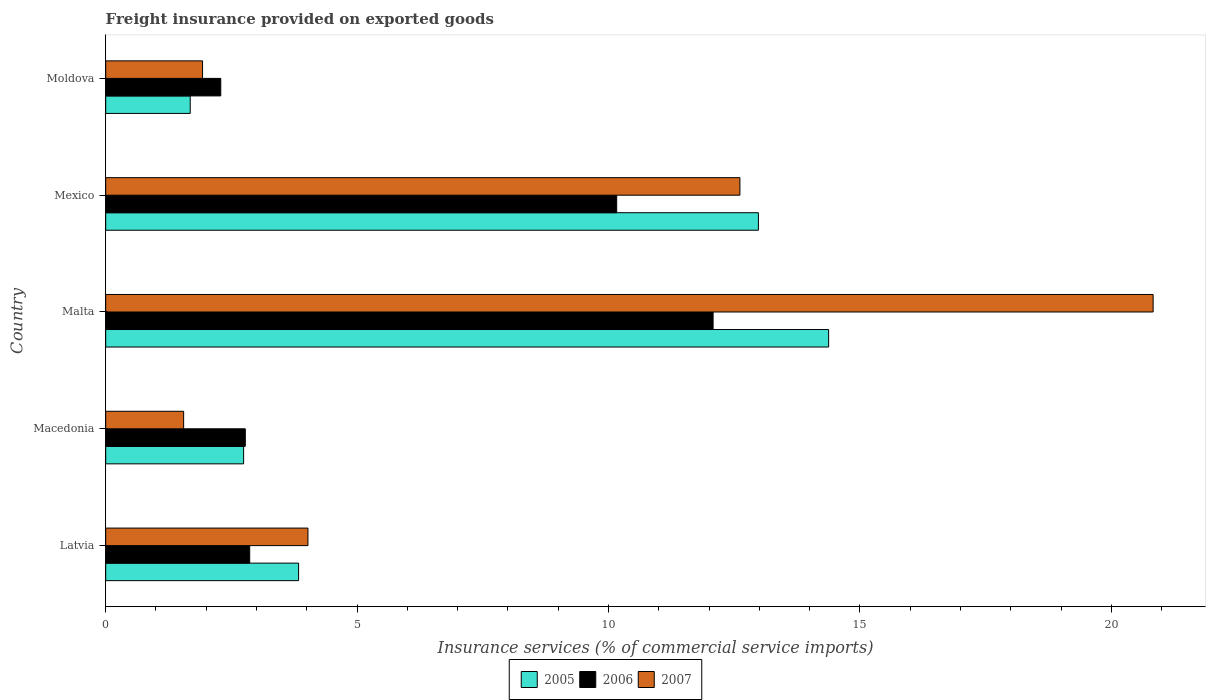How many different coloured bars are there?
Give a very brief answer. 3. How many groups of bars are there?
Your response must be concise. 5. Are the number of bars per tick equal to the number of legend labels?
Provide a succinct answer. Yes. What is the label of the 3rd group of bars from the top?
Your response must be concise. Malta. In how many cases, is the number of bars for a given country not equal to the number of legend labels?
Provide a short and direct response. 0. What is the freight insurance provided on exported goods in 2006 in Moldova?
Keep it short and to the point. 2.29. Across all countries, what is the maximum freight insurance provided on exported goods in 2007?
Make the answer very short. 20.83. Across all countries, what is the minimum freight insurance provided on exported goods in 2005?
Your response must be concise. 1.68. In which country was the freight insurance provided on exported goods in 2005 maximum?
Offer a terse response. Malta. In which country was the freight insurance provided on exported goods in 2006 minimum?
Your response must be concise. Moldova. What is the total freight insurance provided on exported goods in 2005 in the graph?
Your response must be concise. 35.62. What is the difference between the freight insurance provided on exported goods in 2005 in Latvia and that in Malta?
Your answer should be compact. -10.54. What is the difference between the freight insurance provided on exported goods in 2006 in Malta and the freight insurance provided on exported goods in 2005 in Mexico?
Keep it short and to the point. -0.9. What is the average freight insurance provided on exported goods in 2005 per country?
Your answer should be compact. 7.12. What is the difference between the freight insurance provided on exported goods in 2005 and freight insurance provided on exported goods in 2006 in Moldova?
Ensure brevity in your answer.  -0.61. In how many countries, is the freight insurance provided on exported goods in 2005 greater than 3 %?
Make the answer very short. 3. What is the ratio of the freight insurance provided on exported goods in 2005 in Latvia to that in Mexico?
Ensure brevity in your answer.  0.3. Is the difference between the freight insurance provided on exported goods in 2005 in Macedonia and Malta greater than the difference between the freight insurance provided on exported goods in 2006 in Macedonia and Malta?
Offer a very short reply. No. What is the difference between the highest and the second highest freight insurance provided on exported goods in 2006?
Offer a very short reply. 1.92. What is the difference between the highest and the lowest freight insurance provided on exported goods in 2006?
Keep it short and to the point. 9.79. What does the 2nd bar from the top in Moldova represents?
Your answer should be compact. 2006. Where does the legend appear in the graph?
Keep it short and to the point. Bottom center. How many legend labels are there?
Offer a very short reply. 3. What is the title of the graph?
Make the answer very short. Freight insurance provided on exported goods. Does "2010" appear as one of the legend labels in the graph?
Give a very brief answer. No. What is the label or title of the X-axis?
Keep it short and to the point. Insurance services (% of commercial service imports). What is the Insurance services (% of commercial service imports) in 2005 in Latvia?
Keep it short and to the point. 3.84. What is the Insurance services (% of commercial service imports) of 2006 in Latvia?
Make the answer very short. 2.86. What is the Insurance services (% of commercial service imports) in 2007 in Latvia?
Offer a terse response. 4.02. What is the Insurance services (% of commercial service imports) of 2005 in Macedonia?
Give a very brief answer. 2.74. What is the Insurance services (% of commercial service imports) of 2006 in Macedonia?
Give a very brief answer. 2.78. What is the Insurance services (% of commercial service imports) of 2007 in Macedonia?
Offer a terse response. 1.55. What is the Insurance services (% of commercial service imports) of 2005 in Malta?
Keep it short and to the point. 14.38. What is the Insurance services (% of commercial service imports) in 2006 in Malta?
Give a very brief answer. 12.08. What is the Insurance services (% of commercial service imports) of 2007 in Malta?
Ensure brevity in your answer.  20.83. What is the Insurance services (% of commercial service imports) in 2005 in Mexico?
Offer a very short reply. 12.98. What is the Insurance services (% of commercial service imports) of 2006 in Mexico?
Your response must be concise. 10.16. What is the Insurance services (% of commercial service imports) of 2007 in Mexico?
Your answer should be compact. 12.61. What is the Insurance services (% of commercial service imports) of 2005 in Moldova?
Offer a terse response. 1.68. What is the Insurance services (% of commercial service imports) in 2006 in Moldova?
Keep it short and to the point. 2.29. What is the Insurance services (% of commercial service imports) of 2007 in Moldova?
Your answer should be compact. 1.93. Across all countries, what is the maximum Insurance services (% of commercial service imports) in 2005?
Your answer should be very brief. 14.38. Across all countries, what is the maximum Insurance services (% of commercial service imports) in 2006?
Offer a very short reply. 12.08. Across all countries, what is the maximum Insurance services (% of commercial service imports) of 2007?
Make the answer very short. 20.83. Across all countries, what is the minimum Insurance services (% of commercial service imports) of 2005?
Your answer should be compact. 1.68. Across all countries, what is the minimum Insurance services (% of commercial service imports) in 2006?
Your answer should be very brief. 2.29. Across all countries, what is the minimum Insurance services (% of commercial service imports) in 2007?
Make the answer very short. 1.55. What is the total Insurance services (% of commercial service imports) of 2005 in the graph?
Your response must be concise. 35.62. What is the total Insurance services (% of commercial service imports) of 2006 in the graph?
Make the answer very short. 30.17. What is the total Insurance services (% of commercial service imports) in 2007 in the graph?
Provide a succinct answer. 40.94. What is the difference between the Insurance services (% of commercial service imports) of 2005 in Latvia and that in Macedonia?
Ensure brevity in your answer.  1.09. What is the difference between the Insurance services (% of commercial service imports) in 2006 in Latvia and that in Macedonia?
Your answer should be compact. 0.09. What is the difference between the Insurance services (% of commercial service imports) in 2007 in Latvia and that in Macedonia?
Provide a short and direct response. 2.47. What is the difference between the Insurance services (% of commercial service imports) of 2005 in Latvia and that in Malta?
Your answer should be very brief. -10.54. What is the difference between the Insurance services (% of commercial service imports) in 2006 in Latvia and that in Malta?
Offer a very short reply. -9.22. What is the difference between the Insurance services (% of commercial service imports) in 2007 in Latvia and that in Malta?
Your answer should be compact. -16.81. What is the difference between the Insurance services (% of commercial service imports) of 2005 in Latvia and that in Mexico?
Your response must be concise. -9.15. What is the difference between the Insurance services (% of commercial service imports) in 2006 in Latvia and that in Mexico?
Make the answer very short. -7.3. What is the difference between the Insurance services (% of commercial service imports) of 2007 in Latvia and that in Mexico?
Give a very brief answer. -8.59. What is the difference between the Insurance services (% of commercial service imports) of 2005 in Latvia and that in Moldova?
Provide a short and direct response. 2.16. What is the difference between the Insurance services (% of commercial service imports) in 2006 in Latvia and that in Moldova?
Your answer should be compact. 0.58. What is the difference between the Insurance services (% of commercial service imports) of 2007 in Latvia and that in Moldova?
Your response must be concise. 2.1. What is the difference between the Insurance services (% of commercial service imports) in 2005 in Macedonia and that in Malta?
Your answer should be compact. -11.64. What is the difference between the Insurance services (% of commercial service imports) of 2006 in Macedonia and that in Malta?
Offer a very short reply. -9.3. What is the difference between the Insurance services (% of commercial service imports) of 2007 in Macedonia and that in Malta?
Your answer should be compact. -19.28. What is the difference between the Insurance services (% of commercial service imports) in 2005 in Macedonia and that in Mexico?
Provide a succinct answer. -10.24. What is the difference between the Insurance services (% of commercial service imports) of 2006 in Macedonia and that in Mexico?
Your answer should be very brief. -7.39. What is the difference between the Insurance services (% of commercial service imports) of 2007 in Macedonia and that in Mexico?
Your answer should be compact. -11.06. What is the difference between the Insurance services (% of commercial service imports) of 2005 in Macedonia and that in Moldova?
Keep it short and to the point. 1.06. What is the difference between the Insurance services (% of commercial service imports) in 2006 in Macedonia and that in Moldova?
Offer a very short reply. 0.49. What is the difference between the Insurance services (% of commercial service imports) in 2007 in Macedonia and that in Moldova?
Offer a very short reply. -0.38. What is the difference between the Insurance services (% of commercial service imports) of 2005 in Malta and that in Mexico?
Give a very brief answer. 1.4. What is the difference between the Insurance services (% of commercial service imports) of 2006 in Malta and that in Mexico?
Your answer should be very brief. 1.92. What is the difference between the Insurance services (% of commercial service imports) in 2007 in Malta and that in Mexico?
Give a very brief answer. 8.22. What is the difference between the Insurance services (% of commercial service imports) of 2005 in Malta and that in Moldova?
Give a very brief answer. 12.7. What is the difference between the Insurance services (% of commercial service imports) of 2006 in Malta and that in Moldova?
Make the answer very short. 9.79. What is the difference between the Insurance services (% of commercial service imports) of 2007 in Malta and that in Moldova?
Give a very brief answer. 18.91. What is the difference between the Insurance services (% of commercial service imports) in 2005 in Mexico and that in Moldova?
Provide a short and direct response. 11.3. What is the difference between the Insurance services (% of commercial service imports) of 2006 in Mexico and that in Moldova?
Offer a very short reply. 7.87. What is the difference between the Insurance services (% of commercial service imports) of 2007 in Mexico and that in Moldova?
Provide a short and direct response. 10.69. What is the difference between the Insurance services (% of commercial service imports) in 2005 in Latvia and the Insurance services (% of commercial service imports) in 2006 in Macedonia?
Your answer should be very brief. 1.06. What is the difference between the Insurance services (% of commercial service imports) in 2005 in Latvia and the Insurance services (% of commercial service imports) in 2007 in Macedonia?
Offer a terse response. 2.29. What is the difference between the Insurance services (% of commercial service imports) of 2006 in Latvia and the Insurance services (% of commercial service imports) of 2007 in Macedonia?
Your answer should be very brief. 1.31. What is the difference between the Insurance services (% of commercial service imports) in 2005 in Latvia and the Insurance services (% of commercial service imports) in 2006 in Malta?
Offer a very short reply. -8.24. What is the difference between the Insurance services (% of commercial service imports) in 2005 in Latvia and the Insurance services (% of commercial service imports) in 2007 in Malta?
Give a very brief answer. -17. What is the difference between the Insurance services (% of commercial service imports) in 2006 in Latvia and the Insurance services (% of commercial service imports) in 2007 in Malta?
Your response must be concise. -17.97. What is the difference between the Insurance services (% of commercial service imports) in 2005 in Latvia and the Insurance services (% of commercial service imports) in 2006 in Mexico?
Provide a succinct answer. -6.33. What is the difference between the Insurance services (% of commercial service imports) in 2005 in Latvia and the Insurance services (% of commercial service imports) in 2007 in Mexico?
Provide a succinct answer. -8.78. What is the difference between the Insurance services (% of commercial service imports) of 2006 in Latvia and the Insurance services (% of commercial service imports) of 2007 in Mexico?
Your answer should be very brief. -9.75. What is the difference between the Insurance services (% of commercial service imports) in 2005 in Latvia and the Insurance services (% of commercial service imports) in 2006 in Moldova?
Offer a very short reply. 1.55. What is the difference between the Insurance services (% of commercial service imports) of 2005 in Latvia and the Insurance services (% of commercial service imports) of 2007 in Moldova?
Your response must be concise. 1.91. What is the difference between the Insurance services (% of commercial service imports) in 2006 in Latvia and the Insurance services (% of commercial service imports) in 2007 in Moldova?
Offer a very short reply. 0.94. What is the difference between the Insurance services (% of commercial service imports) in 2005 in Macedonia and the Insurance services (% of commercial service imports) in 2006 in Malta?
Provide a succinct answer. -9.34. What is the difference between the Insurance services (% of commercial service imports) of 2005 in Macedonia and the Insurance services (% of commercial service imports) of 2007 in Malta?
Provide a succinct answer. -18.09. What is the difference between the Insurance services (% of commercial service imports) of 2006 in Macedonia and the Insurance services (% of commercial service imports) of 2007 in Malta?
Provide a short and direct response. -18.05. What is the difference between the Insurance services (% of commercial service imports) in 2005 in Macedonia and the Insurance services (% of commercial service imports) in 2006 in Mexico?
Offer a very short reply. -7.42. What is the difference between the Insurance services (% of commercial service imports) in 2005 in Macedonia and the Insurance services (% of commercial service imports) in 2007 in Mexico?
Ensure brevity in your answer.  -9.87. What is the difference between the Insurance services (% of commercial service imports) in 2006 in Macedonia and the Insurance services (% of commercial service imports) in 2007 in Mexico?
Ensure brevity in your answer.  -9.84. What is the difference between the Insurance services (% of commercial service imports) in 2005 in Macedonia and the Insurance services (% of commercial service imports) in 2006 in Moldova?
Provide a succinct answer. 0.45. What is the difference between the Insurance services (% of commercial service imports) in 2005 in Macedonia and the Insurance services (% of commercial service imports) in 2007 in Moldova?
Keep it short and to the point. 0.82. What is the difference between the Insurance services (% of commercial service imports) in 2006 in Macedonia and the Insurance services (% of commercial service imports) in 2007 in Moldova?
Your answer should be compact. 0.85. What is the difference between the Insurance services (% of commercial service imports) of 2005 in Malta and the Insurance services (% of commercial service imports) of 2006 in Mexico?
Your response must be concise. 4.22. What is the difference between the Insurance services (% of commercial service imports) in 2005 in Malta and the Insurance services (% of commercial service imports) in 2007 in Mexico?
Offer a terse response. 1.76. What is the difference between the Insurance services (% of commercial service imports) in 2006 in Malta and the Insurance services (% of commercial service imports) in 2007 in Mexico?
Your answer should be very brief. -0.53. What is the difference between the Insurance services (% of commercial service imports) of 2005 in Malta and the Insurance services (% of commercial service imports) of 2006 in Moldova?
Your answer should be very brief. 12.09. What is the difference between the Insurance services (% of commercial service imports) in 2005 in Malta and the Insurance services (% of commercial service imports) in 2007 in Moldova?
Make the answer very short. 12.45. What is the difference between the Insurance services (% of commercial service imports) in 2006 in Malta and the Insurance services (% of commercial service imports) in 2007 in Moldova?
Give a very brief answer. 10.15. What is the difference between the Insurance services (% of commercial service imports) in 2005 in Mexico and the Insurance services (% of commercial service imports) in 2006 in Moldova?
Provide a short and direct response. 10.69. What is the difference between the Insurance services (% of commercial service imports) of 2005 in Mexico and the Insurance services (% of commercial service imports) of 2007 in Moldova?
Provide a succinct answer. 11.06. What is the difference between the Insurance services (% of commercial service imports) of 2006 in Mexico and the Insurance services (% of commercial service imports) of 2007 in Moldova?
Provide a short and direct response. 8.24. What is the average Insurance services (% of commercial service imports) in 2005 per country?
Your response must be concise. 7.12. What is the average Insurance services (% of commercial service imports) in 2006 per country?
Keep it short and to the point. 6.03. What is the average Insurance services (% of commercial service imports) in 2007 per country?
Provide a succinct answer. 8.19. What is the difference between the Insurance services (% of commercial service imports) in 2005 and Insurance services (% of commercial service imports) in 2006 in Latvia?
Offer a very short reply. 0.97. What is the difference between the Insurance services (% of commercial service imports) of 2005 and Insurance services (% of commercial service imports) of 2007 in Latvia?
Offer a very short reply. -0.19. What is the difference between the Insurance services (% of commercial service imports) of 2006 and Insurance services (% of commercial service imports) of 2007 in Latvia?
Your answer should be compact. -1.16. What is the difference between the Insurance services (% of commercial service imports) of 2005 and Insurance services (% of commercial service imports) of 2006 in Macedonia?
Ensure brevity in your answer.  -0.03. What is the difference between the Insurance services (% of commercial service imports) of 2005 and Insurance services (% of commercial service imports) of 2007 in Macedonia?
Make the answer very short. 1.19. What is the difference between the Insurance services (% of commercial service imports) of 2006 and Insurance services (% of commercial service imports) of 2007 in Macedonia?
Offer a terse response. 1.23. What is the difference between the Insurance services (% of commercial service imports) in 2005 and Insurance services (% of commercial service imports) in 2006 in Malta?
Offer a very short reply. 2.3. What is the difference between the Insurance services (% of commercial service imports) of 2005 and Insurance services (% of commercial service imports) of 2007 in Malta?
Your response must be concise. -6.45. What is the difference between the Insurance services (% of commercial service imports) of 2006 and Insurance services (% of commercial service imports) of 2007 in Malta?
Keep it short and to the point. -8.75. What is the difference between the Insurance services (% of commercial service imports) in 2005 and Insurance services (% of commercial service imports) in 2006 in Mexico?
Offer a very short reply. 2.82. What is the difference between the Insurance services (% of commercial service imports) of 2005 and Insurance services (% of commercial service imports) of 2007 in Mexico?
Give a very brief answer. 0.37. What is the difference between the Insurance services (% of commercial service imports) in 2006 and Insurance services (% of commercial service imports) in 2007 in Mexico?
Provide a short and direct response. -2.45. What is the difference between the Insurance services (% of commercial service imports) of 2005 and Insurance services (% of commercial service imports) of 2006 in Moldova?
Provide a succinct answer. -0.61. What is the difference between the Insurance services (% of commercial service imports) in 2005 and Insurance services (% of commercial service imports) in 2007 in Moldova?
Offer a terse response. -0.25. What is the difference between the Insurance services (% of commercial service imports) of 2006 and Insurance services (% of commercial service imports) of 2007 in Moldova?
Ensure brevity in your answer.  0.36. What is the ratio of the Insurance services (% of commercial service imports) in 2005 in Latvia to that in Macedonia?
Give a very brief answer. 1.4. What is the ratio of the Insurance services (% of commercial service imports) of 2006 in Latvia to that in Macedonia?
Ensure brevity in your answer.  1.03. What is the ratio of the Insurance services (% of commercial service imports) of 2007 in Latvia to that in Macedonia?
Your answer should be very brief. 2.59. What is the ratio of the Insurance services (% of commercial service imports) in 2005 in Latvia to that in Malta?
Offer a very short reply. 0.27. What is the ratio of the Insurance services (% of commercial service imports) in 2006 in Latvia to that in Malta?
Ensure brevity in your answer.  0.24. What is the ratio of the Insurance services (% of commercial service imports) in 2007 in Latvia to that in Malta?
Ensure brevity in your answer.  0.19. What is the ratio of the Insurance services (% of commercial service imports) of 2005 in Latvia to that in Mexico?
Provide a short and direct response. 0.3. What is the ratio of the Insurance services (% of commercial service imports) of 2006 in Latvia to that in Mexico?
Keep it short and to the point. 0.28. What is the ratio of the Insurance services (% of commercial service imports) of 2007 in Latvia to that in Mexico?
Offer a terse response. 0.32. What is the ratio of the Insurance services (% of commercial service imports) of 2005 in Latvia to that in Moldova?
Provide a short and direct response. 2.28. What is the ratio of the Insurance services (% of commercial service imports) of 2006 in Latvia to that in Moldova?
Provide a succinct answer. 1.25. What is the ratio of the Insurance services (% of commercial service imports) of 2007 in Latvia to that in Moldova?
Keep it short and to the point. 2.09. What is the ratio of the Insurance services (% of commercial service imports) of 2005 in Macedonia to that in Malta?
Keep it short and to the point. 0.19. What is the ratio of the Insurance services (% of commercial service imports) of 2006 in Macedonia to that in Malta?
Your response must be concise. 0.23. What is the ratio of the Insurance services (% of commercial service imports) of 2007 in Macedonia to that in Malta?
Your answer should be very brief. 0.07. What is the ratio of the Insurance services (% of commercial service imports) of 2005 in Macedonia to that in Mexico?
Offer a terse response. 0.21. What is the ratio of the Insurance services (% of commercial service imports) of 2006 in Macedonia to that in Mexico?
Offer a terse response. 0.27. What is the ratio of the Insurance services (% of commercial service imports) of 2007 in Macedonia to that in Mexico?
Offer a terse response. 0.12. What is the ratio of the Insurance services (% of commercial service imports) of 2005 in Macedonia to that in Moldova?
Your response must be concise. 1.63. What is the ratio of the Insurance services (% of commercial service imports) in 2006 in Macedonia to that in Moldova?
Your response must be concise. 1.21. What is the ratio of the Insurance services (% of commercial service imports) in 2007 in Macedonia to that in Moldova?
Your answer should be very brief. 0.8. What is the ratio of the Insurance services (% of commercial service imports) in 2005 in Malta to that in Mexico?
Provide a succinct answer. 1.11. What is the ratio of the Insurance services (% of commercial service imports) of 2006 in Malta to that in Mexico?
Ensure brevity in your answer.  1.19. What is the ratio of the Insurance services (% of commercial service imports) of 2007 in Malta to that in Mexico?
Make the answer very short. 1.65. What is the ratio of the Insurance services (% of commercial service imports) in 2005 in Malta to that in Moldova?
Offer a very short reply. 8.55. What is the ratio of the Insurance services (% of commercial service imports) of 2006 in Malta to that in Moldova?
Give a very brief answer. 5.28. What is the ratio of the Insurance services (% of commercial service imports) in 2007 in Malta to that in Moldova?
Your answer should be compact. 10.82. What is the ratio of the Insurance services (% of commercial service imports) of 2005 in Mexico to that in Moldova?
Make the answer very short. 7.72. What is the ratio of the Insurance services (% of commercial service imports) in 2006 in Mexico to that in Moldova?
Provide a short and direct response. 4.44. What is the ratio of the Insurance services (% of commercial service imports) in 2007 in Mexico to that in Moldova?
Offer a very short reply. 6.55. What is the difference between the highest and the second highest Insurance services (% of commercial service imports) in 2005?
Offer a terse response. 1.4. What is the difference between the highest and the second highest Insurance services (% of commercial service imports) in 2006?
Your answer should be compact. 1.92. What is the difference between the highest and the second highest Insurance services (% of commercial service imports) of 2007?
Your answer should be compact. 8.22. What is the difference between the highest and the lowest Insurance services (% of commercial service imports) in 2005?
Your answer should be compact. 12.7. What is the difference between the highest and the lowest Insurance services (% of commercial service imports) of 2006?
Offer a terse response. 9.79. What is the difference between the highest and the lowest Insurance services (% of commercial service imports) of 2007?
Your answer should be compact. 19.28. 